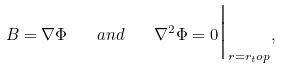Convert formula to latex. <formula><loc_0><loc_0><loc_500><loc_500>B = \nabla \Phi \quad a n d \quad \nabla ^ { 2 } \Phi = 0 { \Big | } _ { r = r _ { t } o p } ,</formula> 